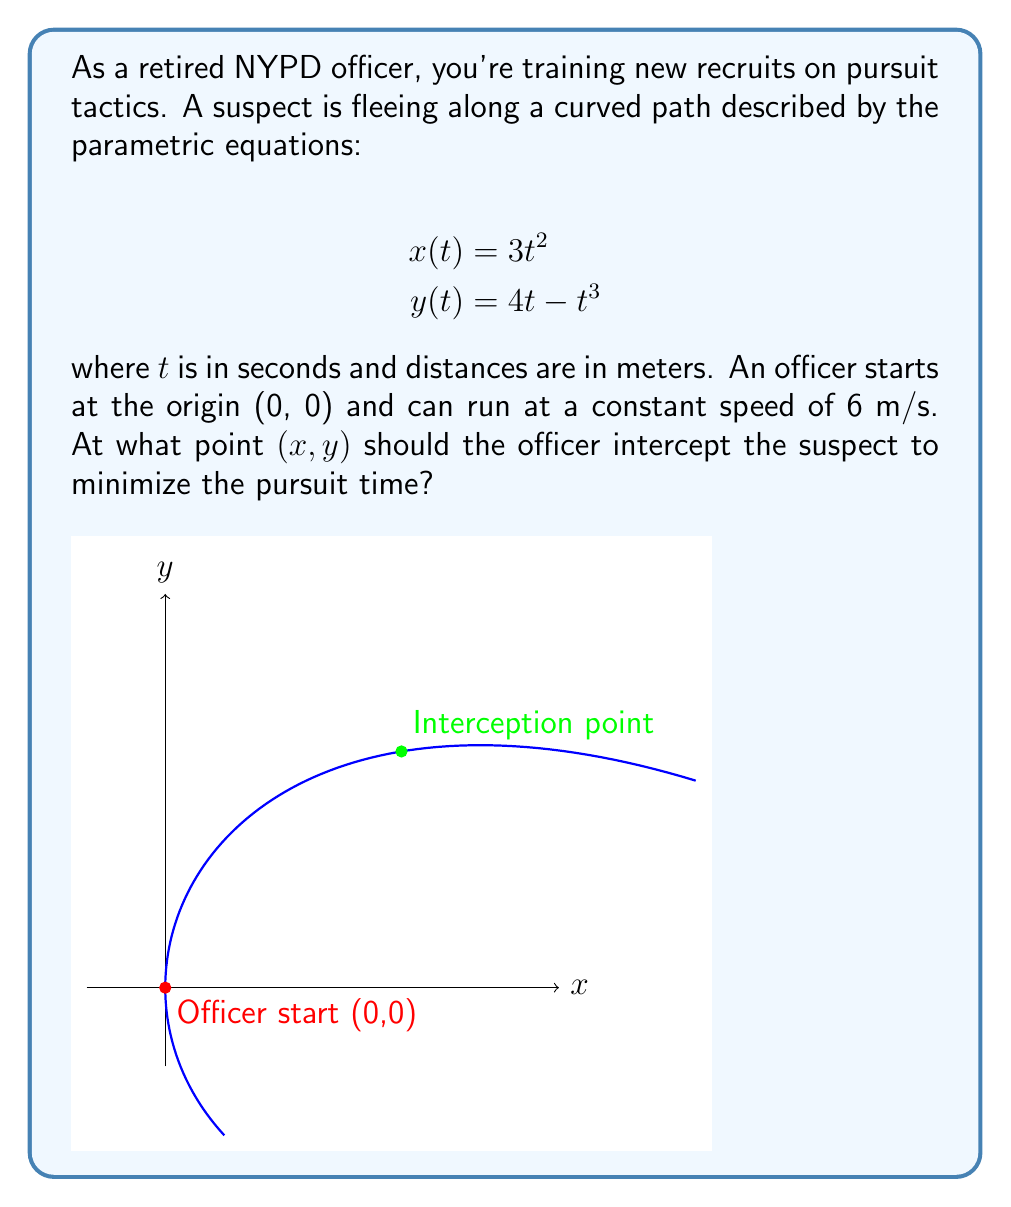Help me with this question. To solve this problem, we'll follow these steps:

1) First, we need to find the parametric velocity of the suspect:
   $$v_x(t) = \frac{dx}{dt} = 6t$$
   $$v_y(t) = \frac{dy}{dt} = 4 - 3t^2$$

2) The speed of the suspect at any time $t$ is:
   $$v(t) = \sqrt{v_x(t)^2 + v_y(t)^2} = \sqrt{36t^2 + (4-3t^2)^2}$$

3) For the optimal interception, the officer should meet the suspect when their speed equals the officer's speed:
   $$\sqrt{36t^2 + (4-3t^2)^2} = 6$$

4) Squaring both sides:
   $$36t^2 + (4-3t^2)^2 = 36$$

5) Expanding:
   $$36t^2 + 16 - 24t^2 + 9t^4 = 36$$
   $$9t^4 + 12t^2 - 20 = 0$$

6) This is a quadratic equation in $t^2$. Let $u = t^2$:
   $$9u^2 + 12u - 20 = 0$$

7) Solving this quadratic equation:
   $$u = \frac{-12 \pm \sqrt{12^2 + 4(9)(20)}}{2(9)} = \frac{-12 \pm \sqrt{864}}{18} = \frac{-12 \pm 29.39}{18}$$

8) We take the positive solution:
   $$u = \frac{-12 + 29.39}{18} = 0.966$$

9) Therefore, $t = \sqrt{0.966} = 0.983$ seconds

10) Substituting this value of $t$ into the original parametric equations:
    $$x = 3(0.983)^2 = 2.90 \text{ meters}$$
    $$y = 4(0.983) - (0.983)^3 = 3.05 \text{ meters}$$

Thus, the optimal interception point is approximately (2.90, 3.05) meters.
Answer: (2.90, 3.05) meters 